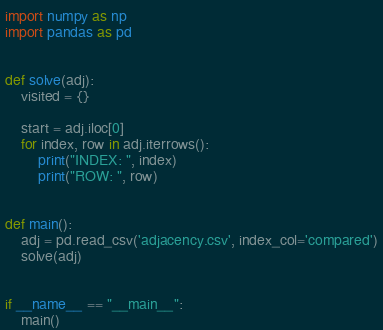Convert code to text. <code><loc_0><loc_0><loc_500><loc_500><_Python_>import numpy as np
import pandas as pd


def solve(adj):
    visited = {}
    
    start = adj.iloc[0]
    for index, row in adj.iterrows():
        print("INDEX: ", index)
        print("ROW: ", row)


def main():
    adj = pd.read_csv('adjacency.csv', index_col='compared')
    solve(adj)


if __name__ == "__main__":
    main()</code> 